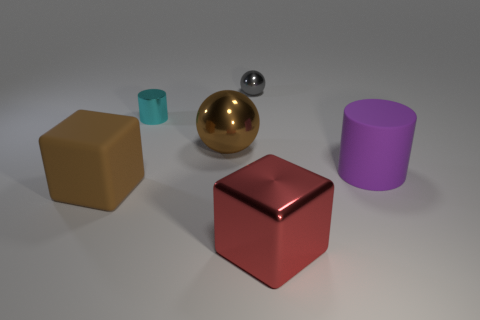There is a ball that is the same color as the matte cube; what material is it?
Provide a succinct answer. Metal. There is a rubber thing that is on the right side of the large metal thing behind the large object that is in front of the big brown matte block; what is its size?
Your response must be concise. Large. Are there more metal objects right of the tiny cyan metallic object than cubes to the left of the large brown rubber cube?
Give a very brief answer. Yes. There is a large brown thing that is in front of the matte cylinder; what number of blocks are in front of it?
Your answer should be very brief. 1. Are there any small cylinders of the same color as the big metallic cube?
Provide a succinct answer. No. Do the gray shiny sphere and the metal cube have the same size?
Your answer should be compact. No. Do the large matte cylinder and the matte cube have the same color?
Your answer should be compact. No. What is the material of the big brown object that is behind the big matte object that is to the right of the small gray metallic sphere?
Provide a succinct answer. Metal. What material is the large object that is the same shape as the tiny gray thing?
Your answer should be compact. Metal. There is a metal thing in front of the brown matte cube; is its size the same as the tiny cyan object?
Give a very brief answer. No. 